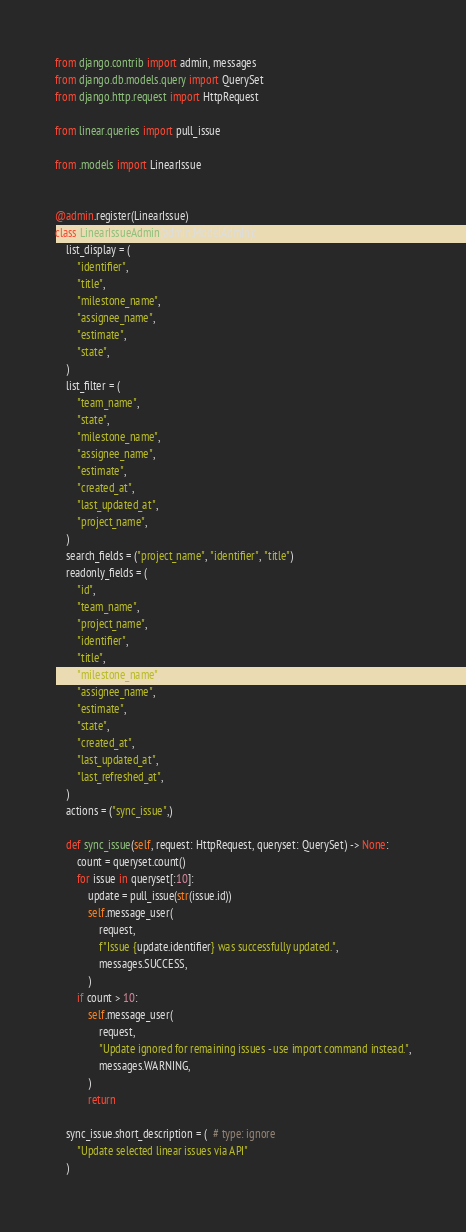<code> <loc_0><loc_0><loc_500><loc_500><_Python_>from django.contrib import admin, messages
from django.db.models.query import QuerySet
from django.http.request import HttpRequest

from linear.queries import pull_issue

from .models import LinearIssue


@admin.register(LinearIssue)
class LinearIssueAdmin(admin.ModelAdmin):
    list_display = (
        "identifier",
        "title",
        "milestone_name",
        "assignee_name",
        "estimate",
        "state",
    )
    list_filter = (
        "team_name",
        "state",
        "milestone_name",
        "assignee_name",
        "estimate",
        "created_at",
        "last_updated_at",
        "project_name",
    )
    search_fields = ("project_name", "identifier", "title")
    readonly_fields = (
        "id",
        "team_name",
        "project_name",
        "identifier",
        "title",
        "milestone_name",
        "assignee_name",
        "estimate",
        "state",
        "created_at",
        "last_updated_at",
        "last_refreshed_at",
    )
    actions = ("sync_issue",)

    def sync_issue(self, request: HttpRequest, queryset: QuerySet) -> None:
        count = queryset.count()
        for issue in queryset[:10]:
            update = pull_issue(str(issue.id))
            self.message_user(
                request,
                f"Issue {update.identifier} was successfully updated.",
                messages.SUCCESS,
            )
        if count > 10:
            self.message_user(
                request,
                "Update ignored for remaining issues - use import command instead.",
                messages.WARNING,
            )
            return

    sync_issue.short_description = (  # type: ignore
        "Update selected linear issues via API"
    )
</code> 